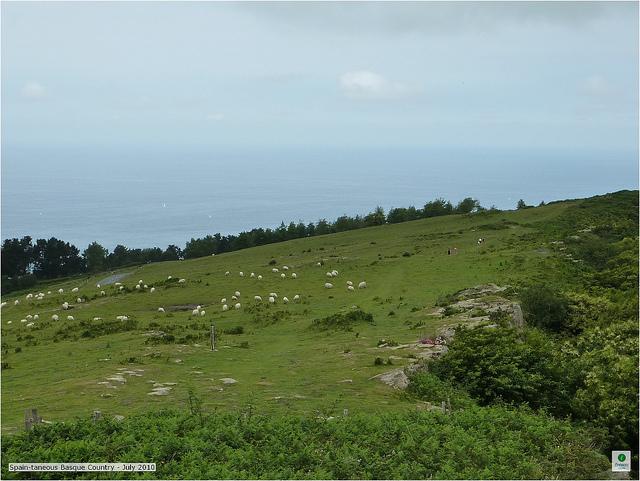Is this a freight train?
Short answer required. No. Is there a body of water in the background?
Write a very short answer. No. Are the animals standing in the grass?
Give a very brief answer. Yes. What animals can be seen on the hill?
Concise answer only. Sheep. Where are the horses?
Be succinct. Field. Where would you be looking if you were sitting on the bench?
Keep it brief. North. Is this picture color?
Answer briefly. Yes. Is this taken in a desert?
Quick response, please. No. Where is the bird?
Keep it brief. Sky. Is the sky clear?
Write a very short answer. Yes. 